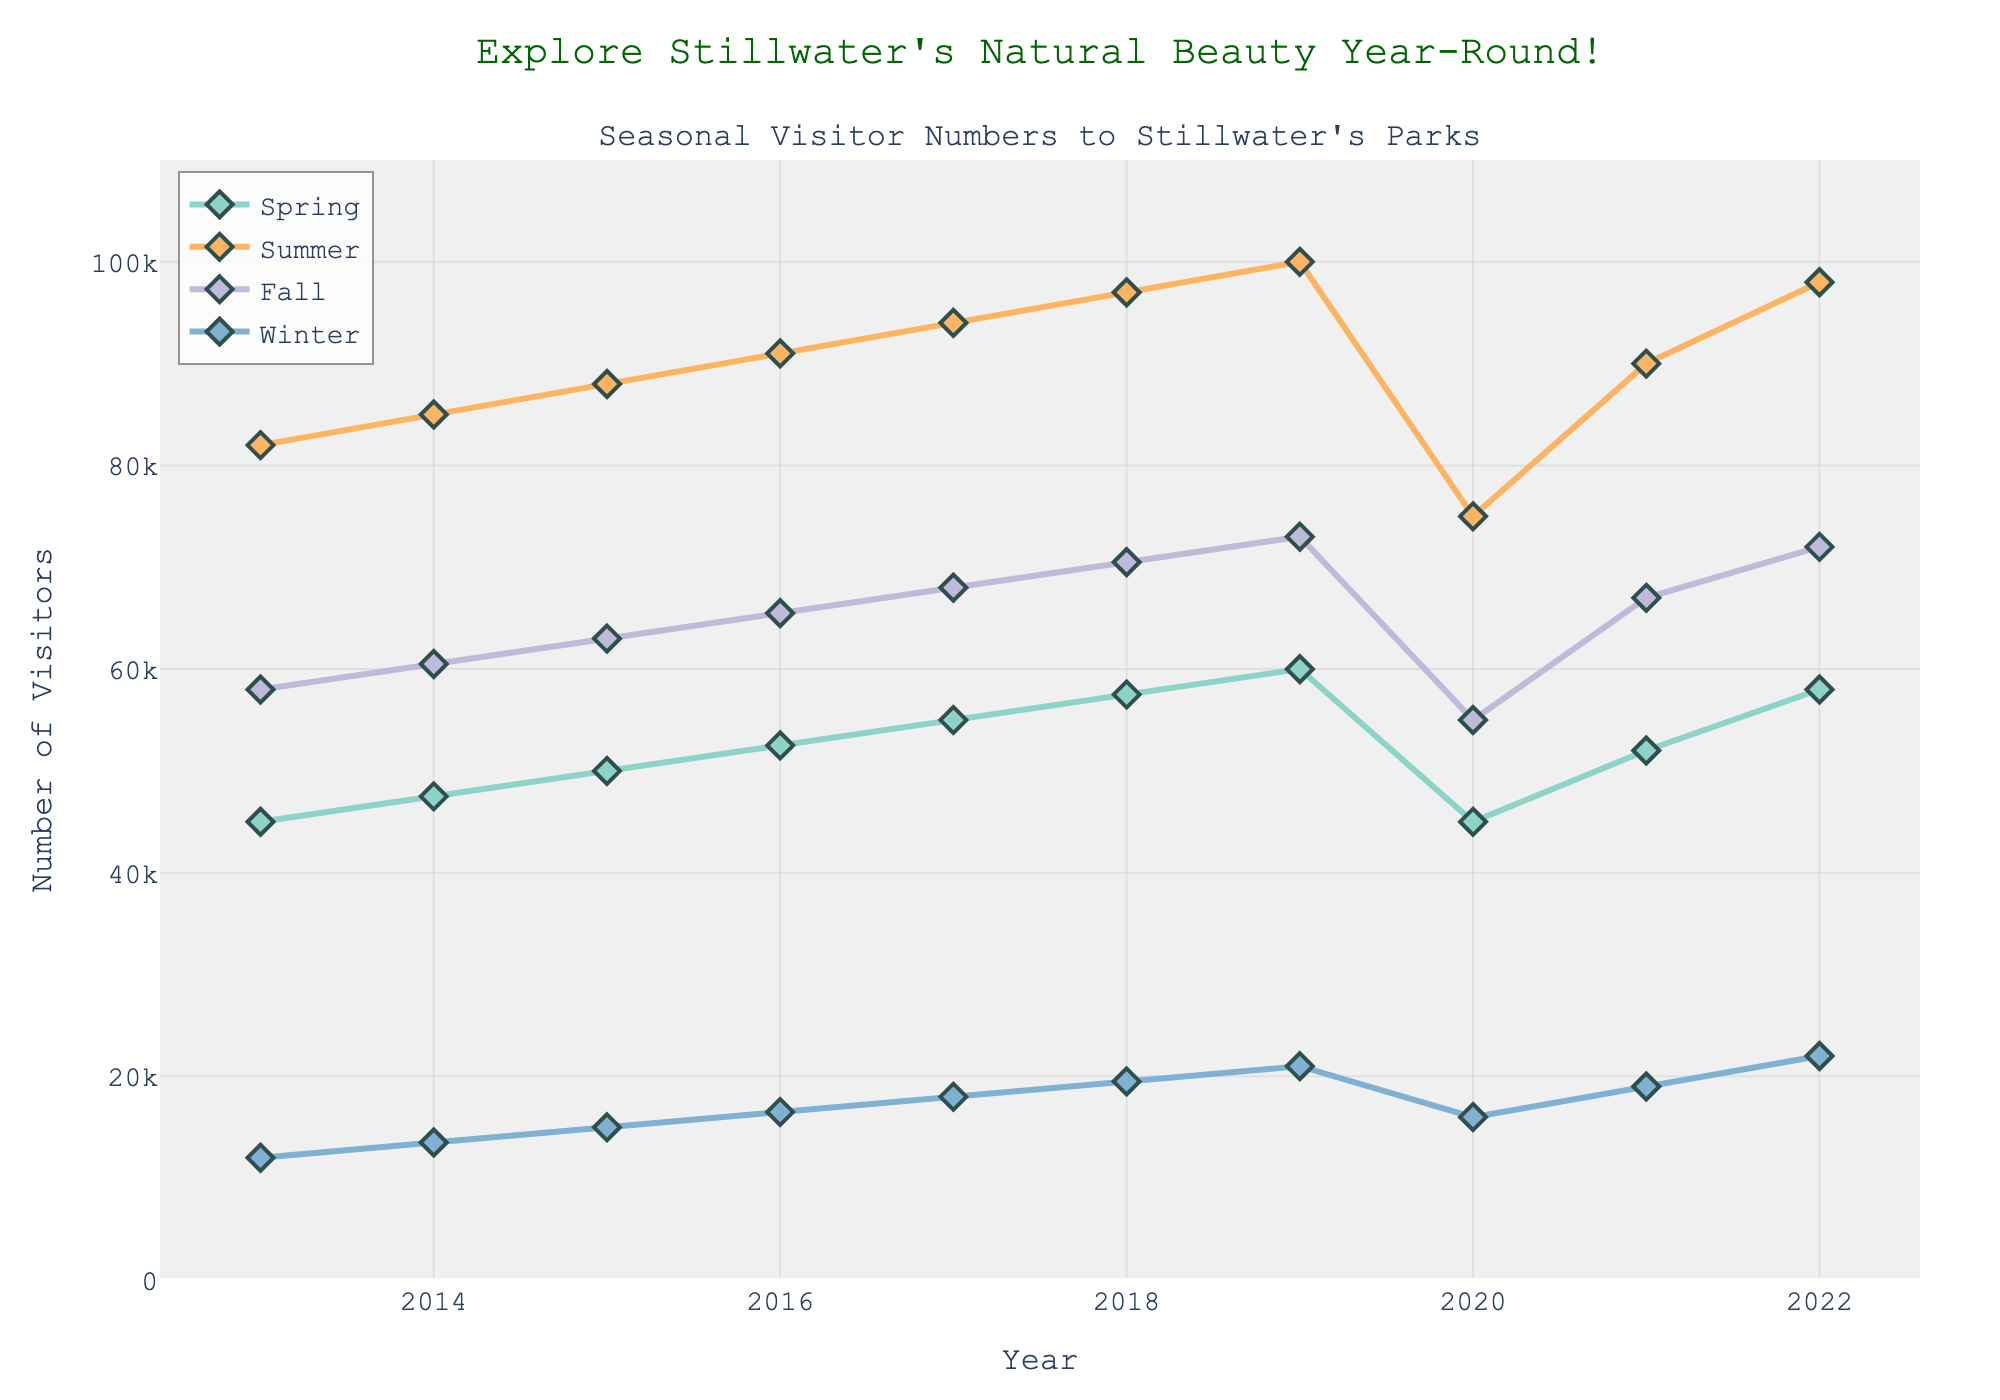What's the trend in visitor numbers during the spring season from 2013 to 2022? To determine the trend, observe the line's direction over time. In this case, the line representing spring visitors trends upwards from 2013 to 2022.
Answer: Increasing Which season had the highest number of visitors in 2020? Look at the 2020 data points and compare the visitor numbers for each season. Summer had the highest bar.
Answer: Summer What is the average number of visitors during winter across the entire decade? Sum all winter visitors from 2013 to 2022 (12000 + 13500 + 15000 + 16500 + 18000 + 19500 + 21000 + 16000 + 19000 + 22000) and divide by the number of years (10). 152000 / 10 = 15200
Answer: 15200 By how much did the number of visitors in the summer of 2022 exceed those in the winter of the same year? Subtract winter visitors in 2022 from summer visitors in 2022: 98000 - 22000 = 76000
Answer: 76000 Which year had the lowest number of summer visitors and what was the corresponding value? Observe the summer visitor numbers across different years. The lowest value occurs in the year 2020, with 75000 visitors.
Answer: 2020, 75000 How did the number of fall visitors change from 2019 to 2020, and what could be the possible explanation? Compare fall visitors in 2019 and 2020. The number decreased from 73000 to 55000, a drop of 18000. This may be due to factors like weather conditions or external events like a pandemic.
Answer: Decreased by 18000 What is the difference between the highest and lowest numbers of spring visitors over the decade? The highest number of spring visitors is in 2022 (58000) and the lowest is in 2013 (45000). The difference is 58000 - 45000 = 13000.
Answer: 13000 Which season consistently had the least number of visitors each year? By examining the graph, we notice that winter consistently had the least number of visitors every year from 2013 to 2022.
Answer: Winter In which year did the number of visitors in spring first exceed 50000? Identify when the spring visitor line first crosses the 50000 mark. This occurred in the year 2015.
Answer: 2015 